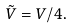Convert formula to latex. <formula><loc_0><loc_0><loc_500><loc_500>\tilde { V } = V / 4 .</formula> 